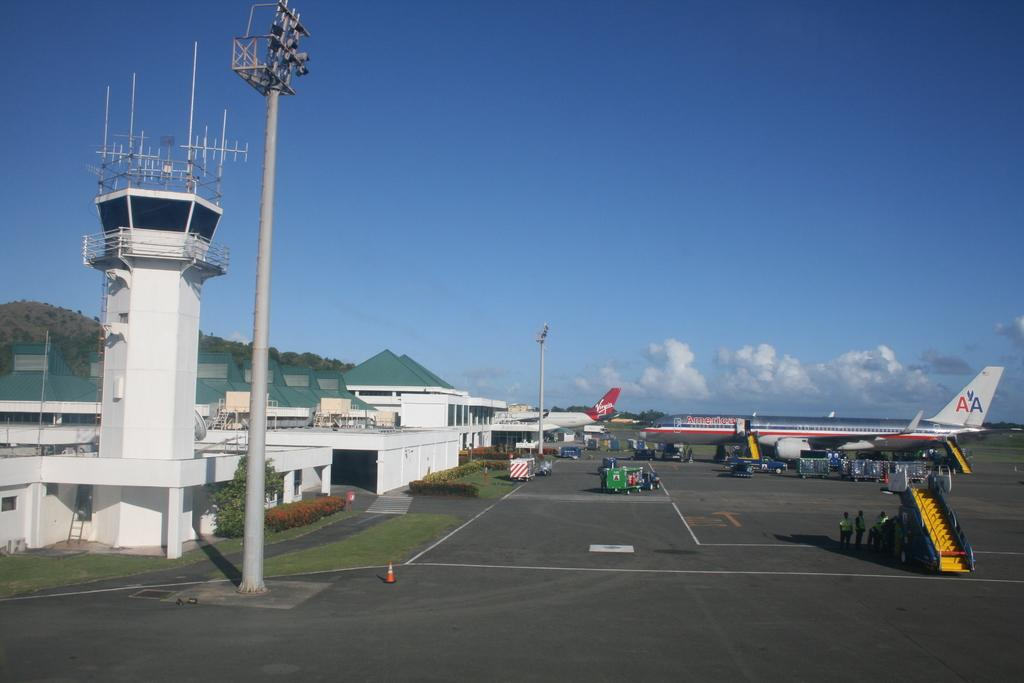Provide a one-sentence caption for the provided image. A plane displaying the American Airlines logo of AA sits at an airport next to a runway. 